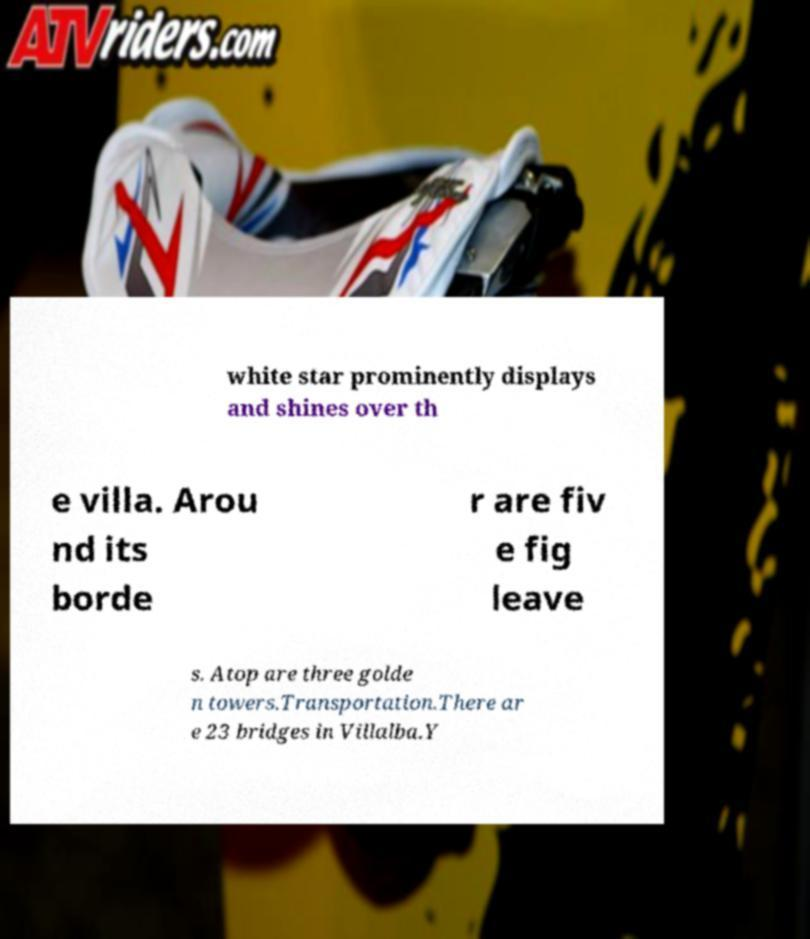For documentation purposes, I need the text within this image transcribed. Could you provide that? white star prominently displays and shines over th e villa. Arou nd its borde r are fiv e fig leave s. Atop are three golde n towers.Transportation.There ar e 23 bridges in Villalba.Y 